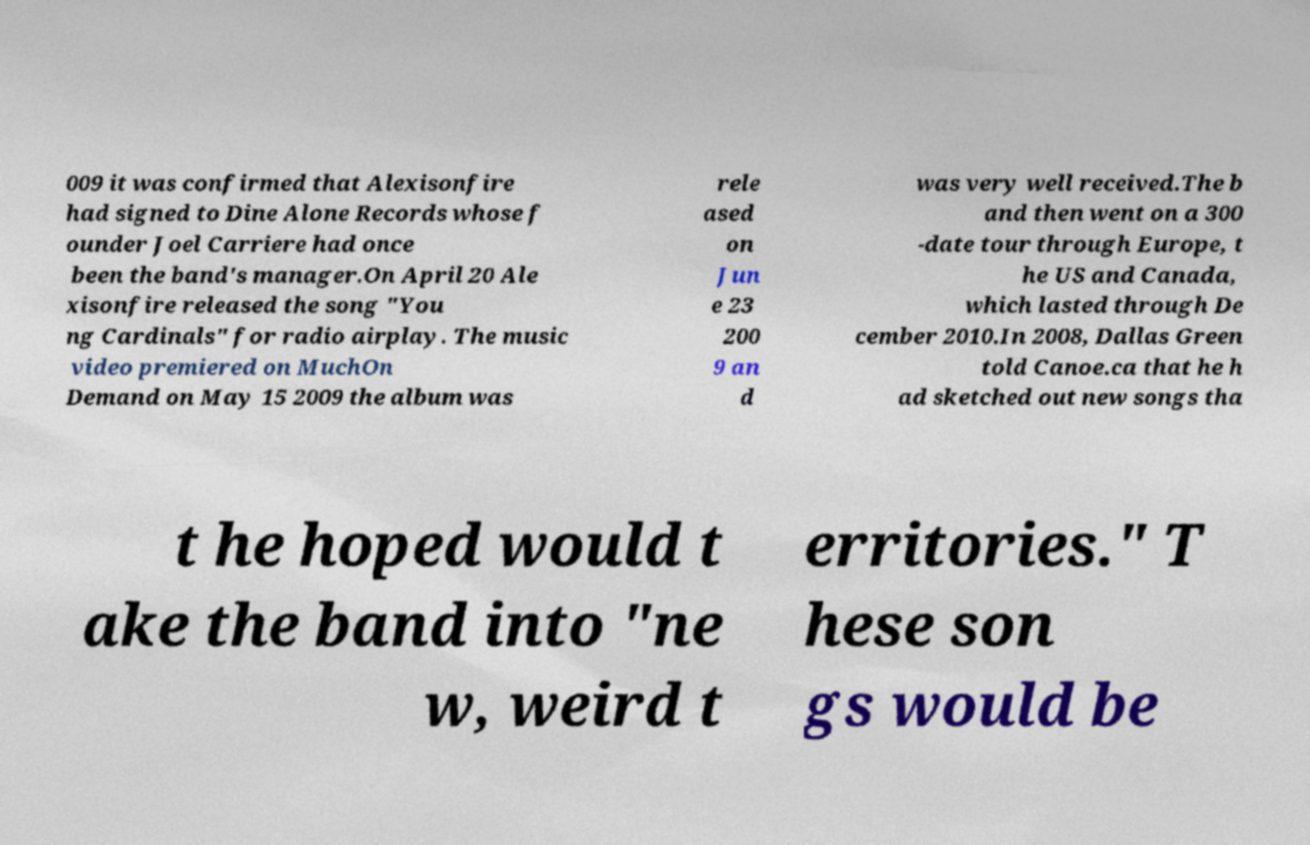Can you read and provide the text displayed in the image?This photo seems to have some interesting text. Can you extract and type it out for me? 009 it was confirmed that Alexisonfire had signed to Dine Alone Records whose f ounder Joel Carriere had once been the band's manager.On April 20 Ale xisonfire released the song "You ng Cardinals" for radio airplay. The music video premiered on MuchOn Demand on May 15 2009 the album was rele ased on Jun e 23 200 9 an d was very well received.The b and then went on a 300 -date tour through Europe, t he US and Canada, which lasted through De cember 2010.In 2008, Dallas Green told Canoe.ca that he h ad sketched out new songs tha t he hoped would t ake the band into "ne w, weird t erritories." T hese son gs would be 